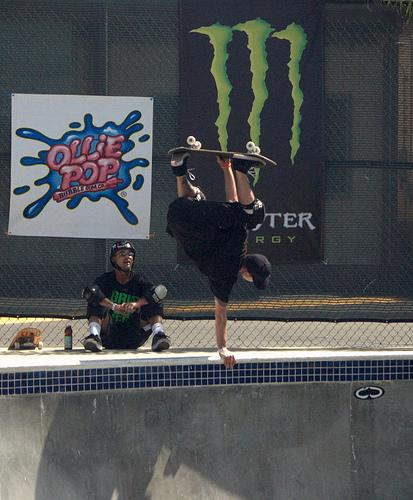What is the narcotic made popular by the poster on the wall? Please explain your reasoning. caffeine. The poster is advertising an energy drink. 